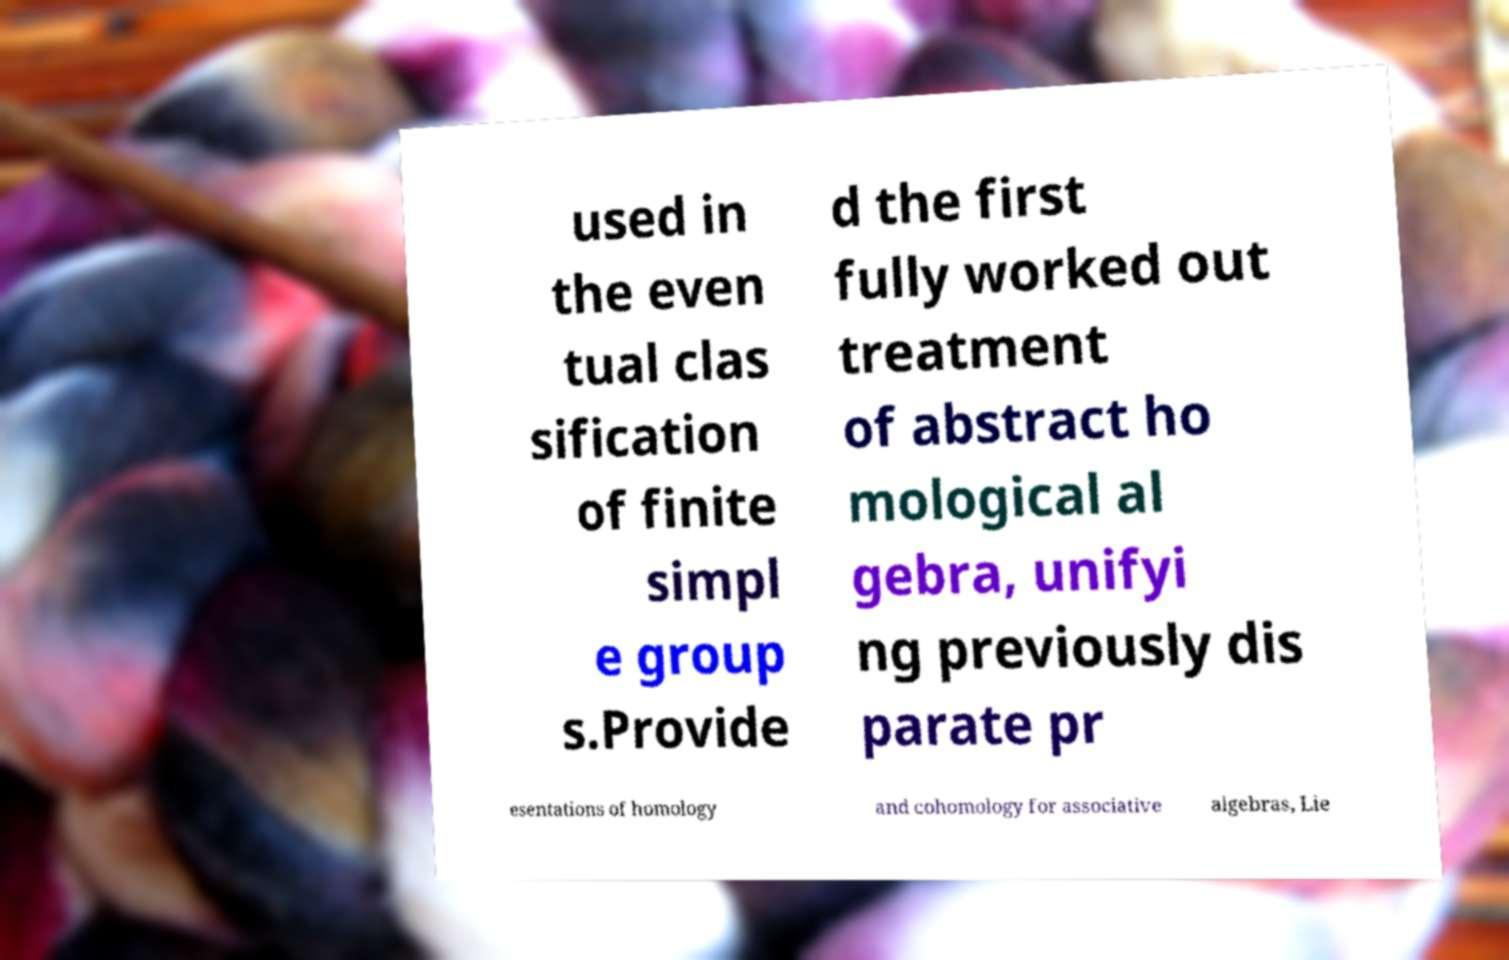There's text embedded in this image that I need extracted. Can you transcribe it verbatim? used in the even tual clas sification of finite simpl e group s.Provide d the first fully worked out treatment of abstract ho mological al gebra, unifyi ng previously dis parate pr esentations of homology and cohomology for associative algebras, Lie 